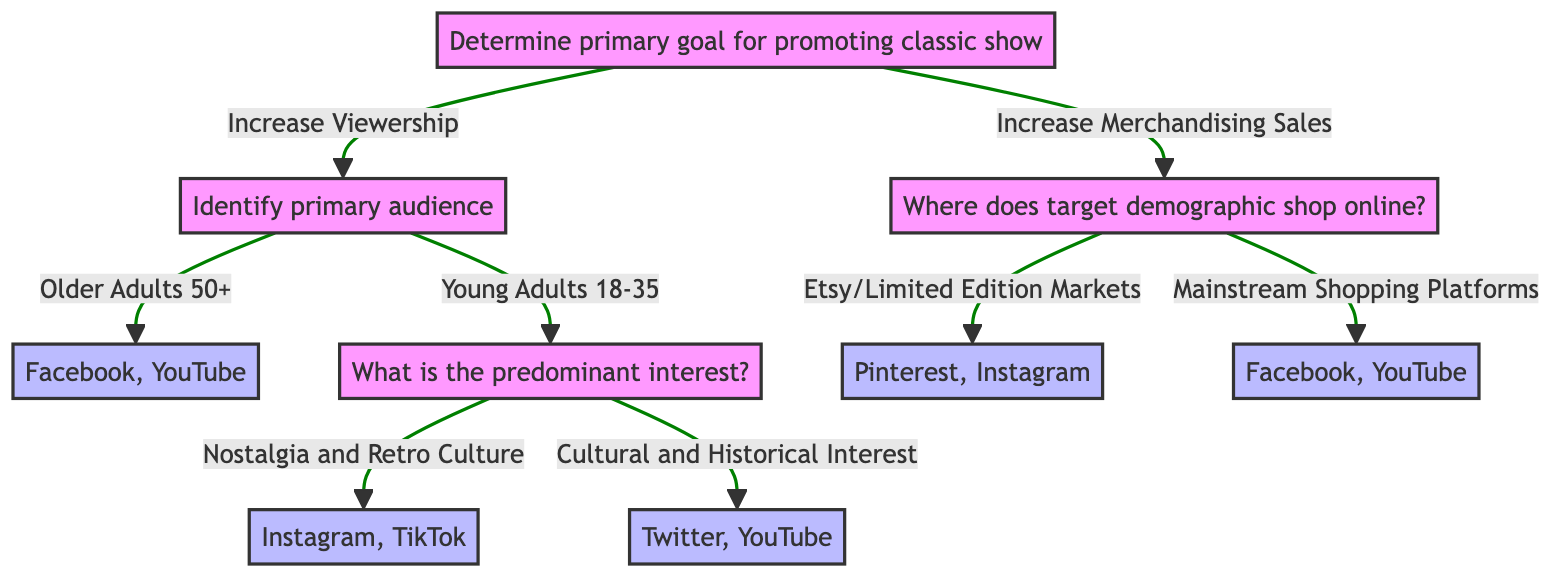What is the primary goal for promoting the classic show? The diagram begins with one main question: "Determine the primary goal for promoting classic show?" This node branches into two choices: "Increase Viewership" and "Increase Merchandising Sales." Thus, the primary goals provided are these two options.
Answer: Increase Viewership, Increase Merchandising Sales How many primary audiences are identified for classic shows? From the diagram, under the branch "Increase Viewership," there are two primary audiences listed: "Older Adults (50+)" and "Young Adults (18-35)." Thus, there are two identified primary audiences.
Answer: 2 Which platforms are recommended for promoting to Older Adults? According to the diagram, if the primary audience is "Older Adults (50+)," the recommended platforms clearly listed under this node are "Facebook" and "YouTube."
Answer: Facebook, YouTube What platforms should be used if targeting Young Adults interested in Nostalgia? The diagram indicates that if the Young Adult audience is interested in "Nostalgia and Retro Culture," the recommended platforms provided are "Instagram" and "TikTok." Thus, these platforms are suggested for this interest category.
Answer: Instagram, TikTok If the goal is to increase merchandising sales and the target demographic shops on Etsy, which platforms are recommended? When the goal is to "Increase Merchandising Sales," if the demographic typically shops in "Etsy/Limited Edition Markets," the platforms suggested in the diagram are "Pinterest" and "Instagram." Therefore, these platforms are ideal for this shopping behavior.
Answer: Pinterest, Instagram Which social media platforms are associated with the "Cultural and Historical Interest" of young adults? The diagram details that for young adults with a focus on "Cultural and Historical Interest," the platforms indicated are "Twitter" and "YouTube." Thus, these would be the platforms to use for this specific audience interest.
Answer: Twitter, YouTube What type of questions does the diagram answer regarding social media promotion? The diagram's structure presents various avenues to determine social media promotion strategies by identifying goals, audiences, and interests, allowing it to effectively categorize recommendations. This type is indicative of a decision tree where questions guide users to specific conclusions.
Answer: Yes, Decision Tree Questions What is the next step after determining the goal is to "Increase Merchandising Sales"? If a user follows the path where the goal is "Increase Merchandising Sales," the next question they must consider is: "Where does your target demographic usually shop online?" This guides the subsequent decision-making process directly related to the merchandising goal.
Answer: Where does your target demographic usually shop online? 